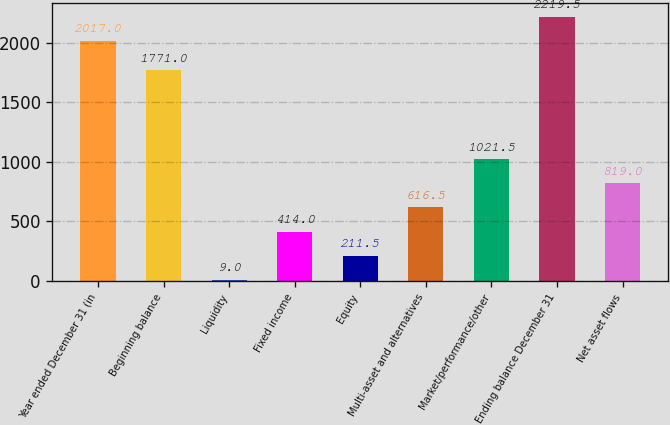<chart> <loc_0><loc_0><loc_500><loc_500><bar_chart><fcel>Year ended December 31 (in<fcel>Beginning balance<fcel>Liquidity<fcel>Fixed income<fcel>Equity<fcel>Multi-asset and alternatives<fcel>Market/performance/other<fcel>Ending balance December 31<fcel>Net asset flows<nl><fcel>2017<fcel>1771<fcel>9<fcel>414<fcel>211.5<fcel>616.5<fcel>1021.5<fcel>2219.5<fcel>819<nl></chart> 